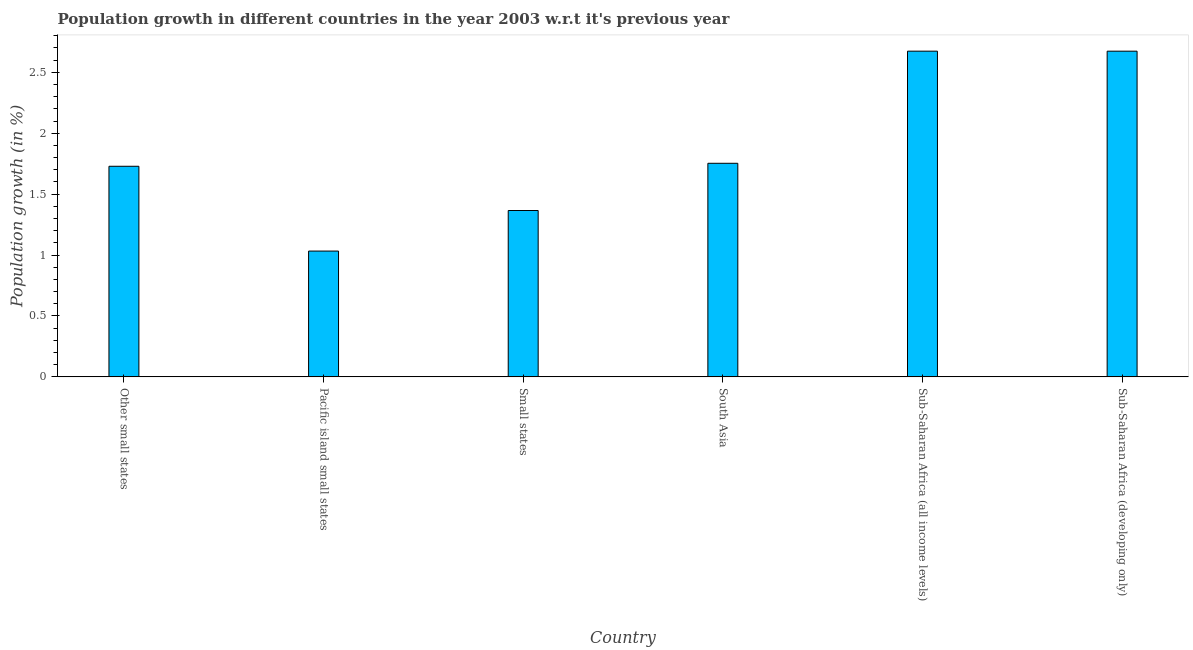Does the graph contain grids?
Your answer should be very brief. No. What is the title of the graph?
Ensure brevity in your answer.  Population growth in different countries in the year 2003 w.r.t it's previous year. What is the label or title of the Y-axis?
Provide a succinct answer. Population growth (in %). What is the population growth in Other small states?
Provide a short and direct response. 1.73. Across all countries, what is the maximum population growth?
Your answer should be very brief. 2.67. Across all countries, what is the minimum population growth?
Your response must be concise. 1.03. In which country was the population growth maximum?
Make the answer very short. Sub-Saharan Africa (all income levels). In which country was the population growth minimum?
Keep it short and to the point. Pacific island small states. What is the sum of the population growth?
Offer a very short reply. 11.23. What is the difference between the population growth in Other small states and Sub-Saharan Africa (all income levels)?
Your response must be concise. -0.94. What is the average population growth per country?
Make the answer very short. 1.87. What is the median population growth?
Your response must be concise. 1.74. What is the ratio of the population growth in Other small states to that in Sub-Saharan Africa (developing only)?
Your response must be concise. 0.65. Is the difference between the population growth in South Asia and Sub-Saharan Africa (developing only) greater than the difference between any two countries?
Provide a succinct answer. No. What is the difference between the highest and the second highest population growth?
Your answer should be compact. 0. Is the sum of the population growth in Small states and Sub-Saharan Africa (developing only) greater than the maximum population growth across all countries?
Your response must be concise. Yes. What is the difference between the highest and the lowest population growth?
Provide a short and direct response. 1.64. How many bars are there?
Make the answer very short. 6. How many countries are there in the graph?
Offer a terse response. 6. What is the Population growth (in %) in Other small states?
Provide a short and direct response. 1.73. What is the Population growth (in %) in Pacific island small states?
Your response must be concise. 1.03. What is the Population growth (in %) in Small states?
Make the answer very short. 1.37. What is the Population growth (in %) of South Asia?
Your response must be concise. 1.75. What is the Population growth (in %) of Sub-Saharan Africa (all income levels)?
Give a very brief answer. 2.67. What is the Population growth (in %) in Sub-Saharan Africa (developing only)?
Provide a succinct answer. 2.67. What is the difference between the Population growth (in %) in Other small states and Pacific island small states?
Your answer should be very brief. 0.7. What is the difference between the Population growth (in %) in Other small states and Small states?
Keep it short and to the point. 0.36. What is the difference between the Population growth (in %) in Other small states and South Asia?
Ensure brevity in your answer.  -0.02. What is the difference between the Population growth (in %) in Other small states and Sub-Saharan Africa (all income levels)?
Your response must be concise. -0.94. What is the difference between the Population growth (in %) in Other small states and Sub-Saharan Africa (developing only)?
Give a very brief answer. -0.94. What is the difference between the Population growth (in %) in Pacific island small states and Small states?
Make the answer very short. -0.33. What is the difference between the Population growth (in %) in Pacific island small states and South Asia?
Provide a short and direct response. -0.72. What is the difference between the Population growth (in %) in Pacific island small states and Sub-Saharan Africa (all income levels)?
Provide a short and direct response. -1.64. What is the difference between the Population growth (in %) in Pacific island small states and Sub-Saharan Africa (developing only)?
Keep it short and to the point. -1.64. What is the difference between the Population growth (in %) in Small states and South Asia?
Provide a short and direct response. -0.39. What is the difference between the Population growth (in %) in Small states and Sub-Saharan Africa (all income levels)?
Offer a very short reply. -1.31. What is the difference between the Population growth (in %) in Small states and Sub-Saharan Africa (developing only)?
Keep it short and to the point. -1.31. What is the difference between the Population growth (in %) in South Asia and Sub-Saharan Africa (all income levels)?
Keep it short and to the point. -0.92. What is the difference between the Population growth (in %) in South Asia and Sub-Saharan Africa (developing only)?
Make the answer very short. -0.92. What is the difference between the Population growth (in %) in Sub-Saharan Africa (all income levels) and Sub-Saharan Africa (developing only)?
Your response must be concise. 0. What is the ratio of the Population growth (in %) in Other small states to that in Pacific island small states?
Provide a short and direct response. 1.67. What is the ratio of the Population growth (in %) in Other small states to that in Small states?
Offer a terse response. 1.27. What is the ratio of the Population growth (in %) in Other small states to that in South Asia?
Ensure brevity in your answer.  0.99. What is the ratio of the Population growth (in %) in Other small states to that in Sub-Saharan Africa (all income levels)?
Offer a very short reply. 0.65. What is the ratio of the Population growth (in %) in Other small states to that in Sub-Saharan Africa (developing only)?
Ensure brevity in your answer.  0.65. What is the ratio of the Population growth (in %) in Pacific island small states to that in Small states?
Give a very brief answer. 0.76. What is the ratio of the Population growth (in %) in Pacific island small states to that in South Asia?
Your answer should be compact. 0.59. What is the ratio of the Population growth (in %) in Pacific island small states to that in Sub-Saharan Africa (all income levels)?
Provide a short and direct response. 0.39. What is the ratio of the Population growth (in %) in Pacific island small states to that in Sub-Saharan Africa (developing only)?
Give a very brief answer. 0.39. What is the ratio of the Population growth (in %) in Small states to that in South Asia?
Offer a very short reply. 0.78. What is the ratio of the Population growth (in %) in Small states to that in Sub-Saharan Africa (all income levels)?
Your response must be concise. 0.51. What is the ratio of the Population growth (in %) in Small states to that in Sub-Saharan Africa (developing only)?
Your answer should be very brief. 0.51. What is the ratio of the Population growth (in %) in South Asia to that in Sub-Saharan Africa (all income levels)?
Offer a very short reply. 0.66. What is the ratio of the Population growth (in %) in South Asia to that in Sub-Saharan Africa (developing only)?
Offer a very short reply. 0.66. What is the ratio of the Population growth (in %) in Sub-Saharan Africa (all income levels) to that in Sub-Saharan Africa (developing only)?
Ensure brevity in your answer.  1. 